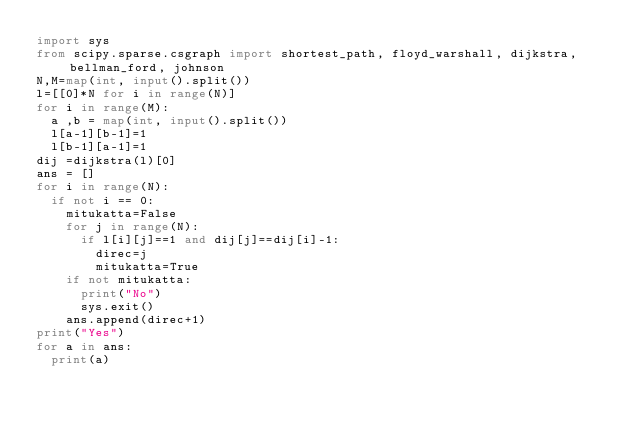Convert code to text. <code><loc_0><loc_0><loc_500><loc_500><_Python_>import sys
from scipy.sparse.csgraph import shortest_path, floyd_warshall, dijkstra, bellman_ford, johnson
N,M=map(int, input().split())
l=[[0]*N for i in range(N)]
for i in range(M):
  a ,b = map(int, input().split())
  l[a-1][b-1]=1
  l[b-1][a-1]=1
dij =dijkstra(l)[0]
ans = []
for i in range(N):
  if not i == 0:
    mitukatta=False
    for j in range(N):
      if l[i][j]==1 and dij[j]==dij[i]-1:
        direc=j
        mitukatta=True
    if not mitukatta:
      print("No")
      sys.exit()
    ans.append(direc+1)
print("Yes")
for a in ans:
  print(a)</code> 